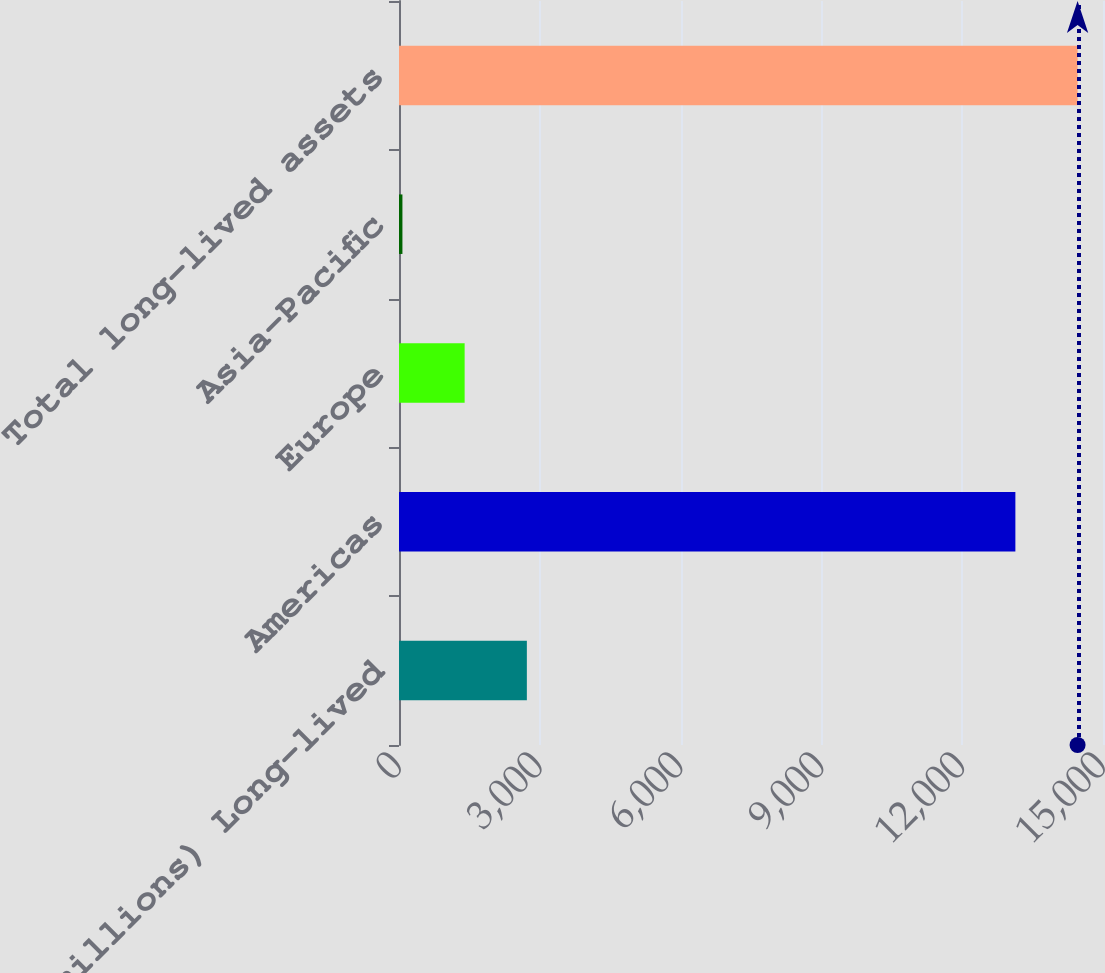Convert chart. <chart><loc_0><loc_0><loc_500><loc_500><bar_chart><fcel>(in millions) Long-lived<fcel>Americas<fcel>Europe<fcel>Asia-Pacific<fcel>Total long-lived assets<nl><fcel>2724.2<fcel>13133<fcel>1398.6<fcel>73<fcel>14458.6<nl></chart> 